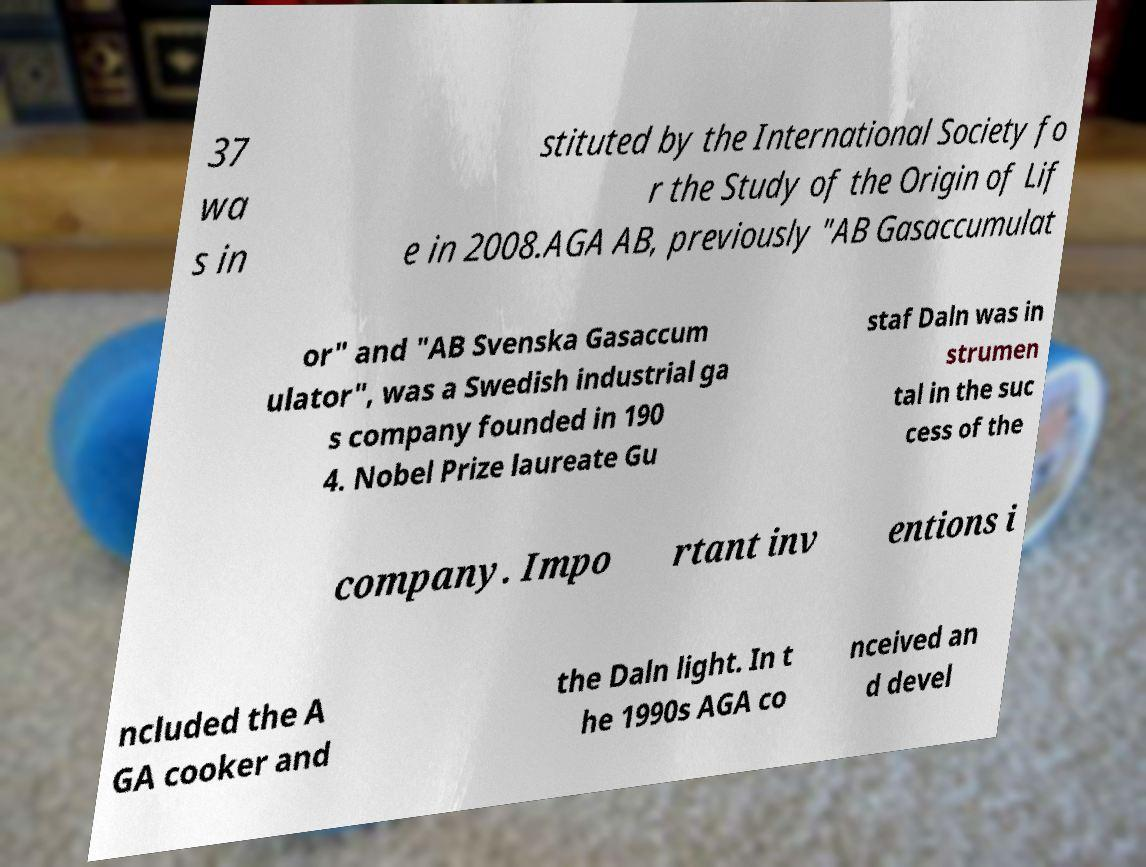Can you read and provide the text displayed in the image?This photo seems to have some interesting text. Can you extract and type it out for me? 37 wa s in stituted by the International Society fo r the Study of the Origin of Lif e in 2008.AGA AB, previously "AB Gasaccumulat or" and "AB Svenska Gasaccum ulator", was a Swedish industrial ga s company founded in 190 4. Nobel Prize laureate Gu staf Daln was in strumen tal in the suc cess of the company. Impo rtant inv entions i ncluded the A GA cooker and the Daln light. In t he 1990s AGA co nceived an d devel 